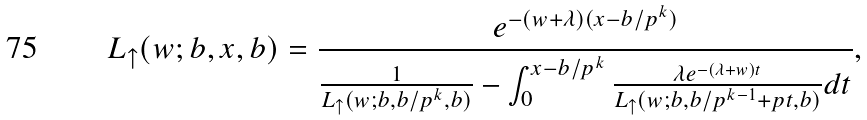Convert formula to latex. <formula><loc_0><loc_0><loc_500><loc_500>L _ { \uparrow } ( w ; b , x , b ) = \frac { e ^ { - ( w + \lambda ) ( x - b / p ^ { k } ) } } { \frac { 1 } { L _ { \uparrow } ( w ; b , b / p ^ { k } , b ) } - \int _ { 0 } ^ { x - b / p ^ { k } } \frac { \lambda e ^ { - ( \lambda + w ) t } } { L _ { \uparrow } ( w ; b , b / p ^ { k - 1 } + p t , b ) } d t } ,</formula> 